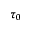<formula> <loc_0><loc_0><loc_500><loc_500>\tau _ { 0 }</formula> 